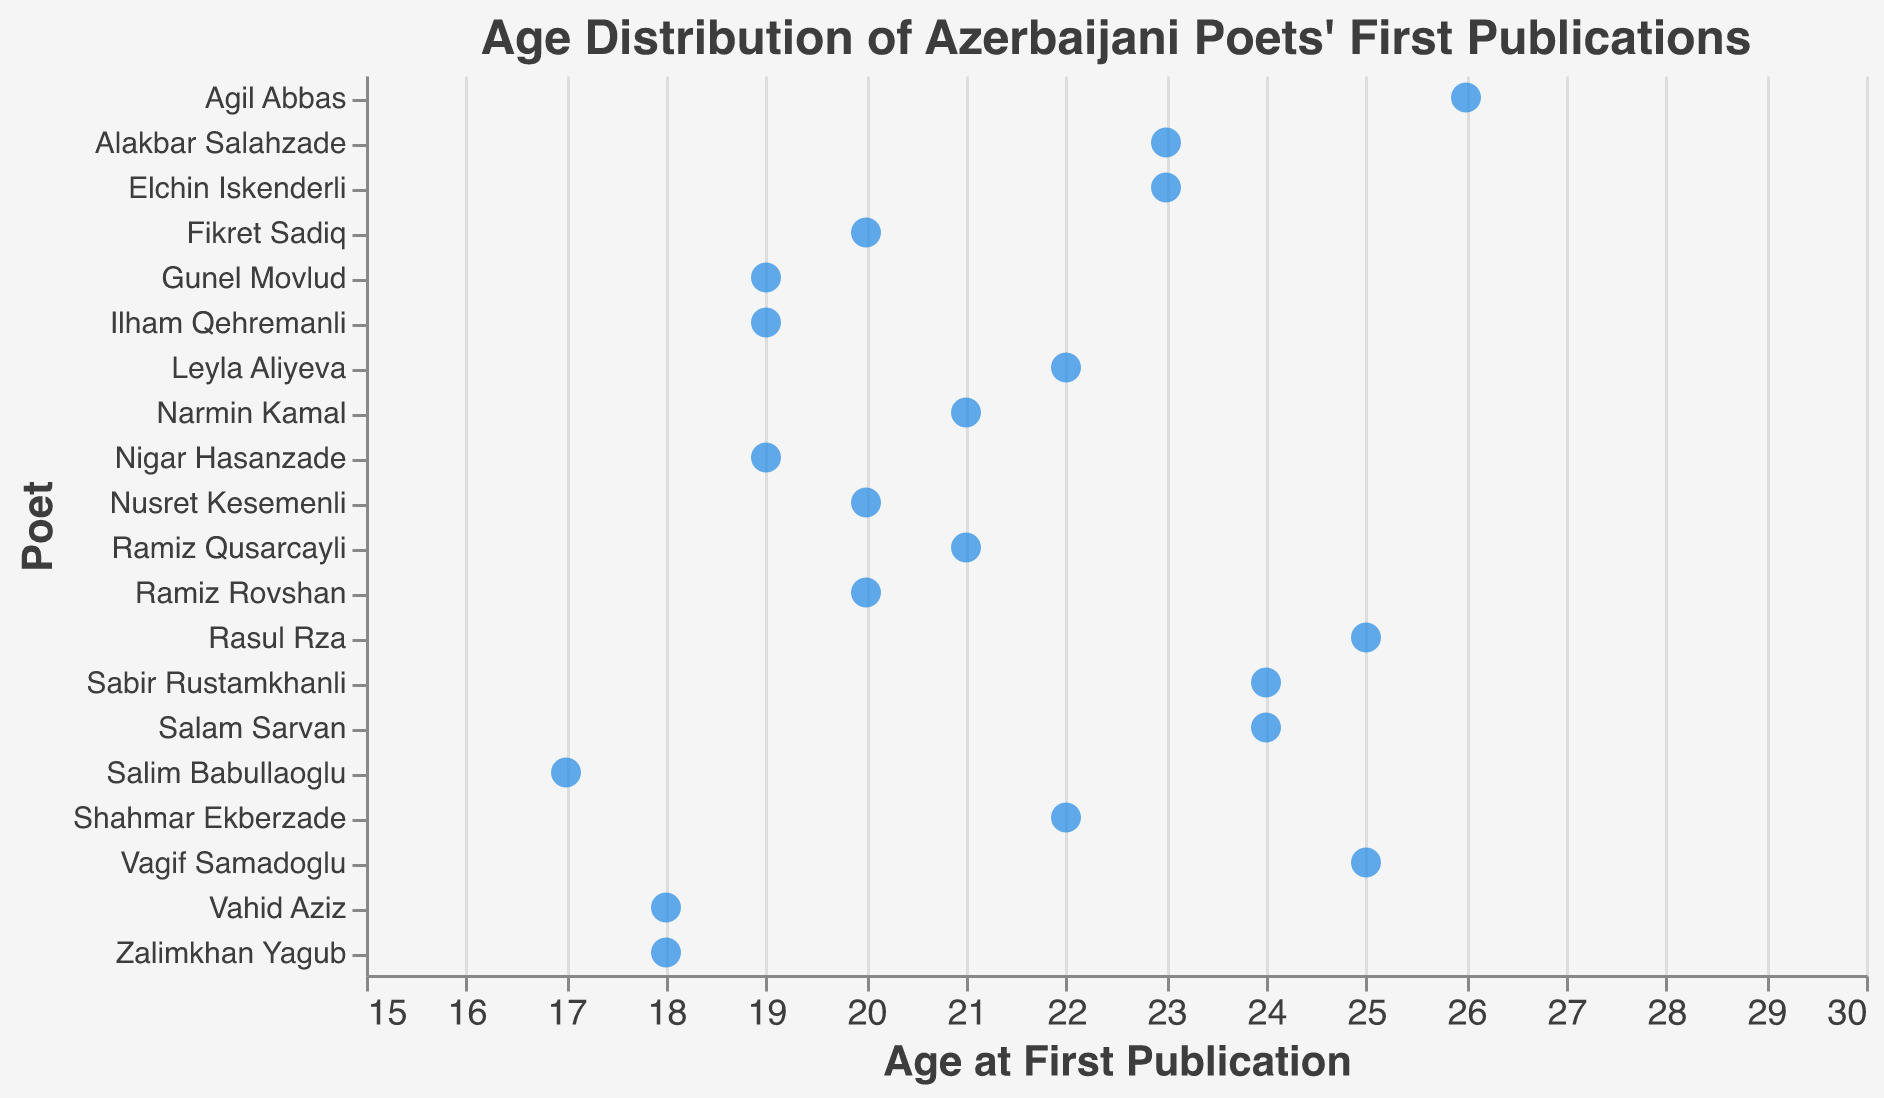Which poet published their first work at the youngest age? The figure shows the ages at which each Poet first published their work. The youngest age displayed is 17, attributed to Salim Babullaoglu.
Answer: Salim Babullaoglu What is the range of ages at which poets first published their work? The figure indicates the ages on the x-axis from the youngest to the oldest poet. The youngest is Salim Babullaoglu at 17 and the oldest is Agil Abbas at 26. The range is 26 - 17 = 9.
Answer: 9 How many poets first published their work at age 19? By counting the points lined up at age 19 on the x-axis, we see three poets: Nigar Hasanzade, Gunel Movlud, and Ilham Qehremanli.
Answer: 3 Who are the poets that published their first work at age 23? By inspecting the data points associated with the age 23 on the x-axis, we can identify the poets. They are Alakbar Salahzade and Elchin Iskenderli.
Answer: Alakbar Salahzade, Elchin Iskenderli What's the median age of the poets when they first published their work? To find the median, we first list out all ages in ascending order and find the middle value. The ages are: 17, 18, 18, 19, 19, 19, 20, 20, 20, 21, 21, 22, 22, 23, 23, 24, 24, 25, 25, 26. With 20 data points, the median is the average of the 10th and 11th values, which are both 21.
Answer: 21 Which poets first published their work at age 25? By looking at the data points on the x-axis corresponding to age 25, we can identify the poets. They are Rasul Rza and Vagif Samadoglu.
Answer: Rasul Rza, Vagif Samadoglu Is there any poet who published their work at age 20? If so, who are they? The x-axis data points at age 20 indicate three poets. They are Ramiz Rovshan, Fikret Sadiq, and Nusret Kesemenli.
Answer: Ramiz Rovshan, Fikret Sadiq, Nusret Kesemenli Does any poet share the same first publication age with another poet? Yes, several poets share the same age at their first publication as indicated by overlapping points on the x-axis, such as age 19 (Nigar Hasanzade, Gunel Movlud, Ilham Qehremanli), age 20 (Ramiz Rovshan, Fikret Sadiq, Nusret Kesemenli), and others.
Answer: Yes What is the age where the second highest number of poets published their first work? Counting the data points at each age, we see that the age 20 has three poets, which is the second highest number of poets for a single age after 19.
Answer: Age 20 